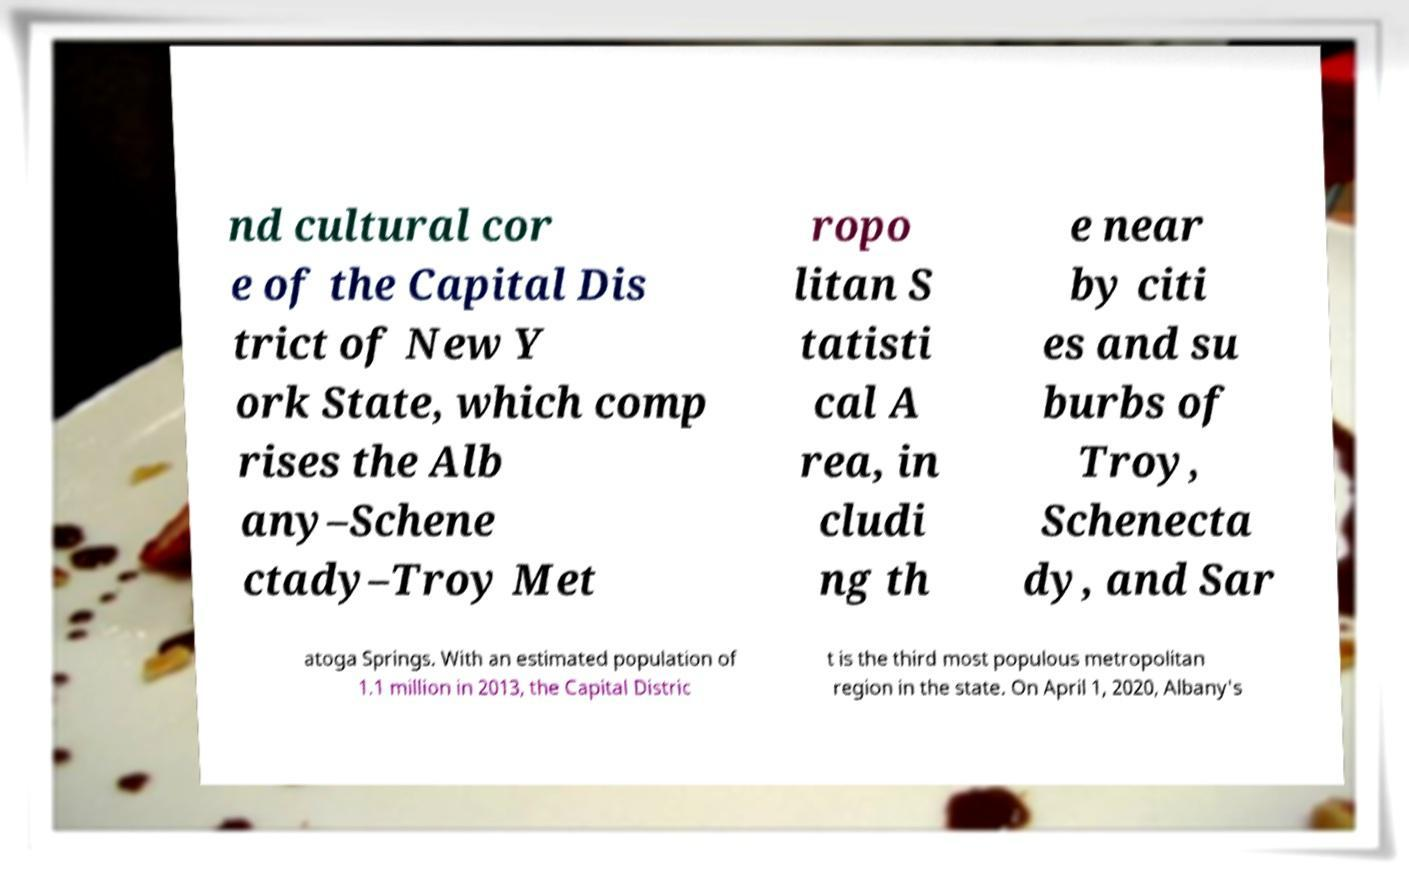I need the written content from this picture converted into text. Can you do that? nd cultural cor e of the Capital Dis trict of New Y ork State, which comp rises the Alb any–Schene ctady–Troy Met ropo litan S tatisti cal A rea, in cludi ng th e near by citi es and su burbs of Troy, Schenecta dy, and Sar atoga Springs. With an estimated population of 1.1 million in 2013, the Capital Distric t is the third most populous metropolitan region in the state. On April 1, 2020, Albany's 